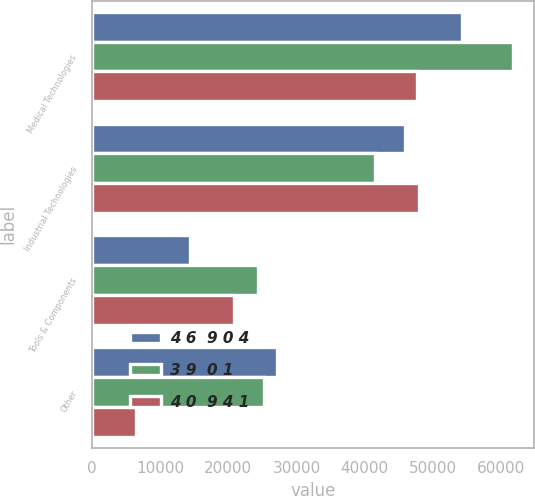<chart> <loc_0><loc_0><loc_500><loc_500><stacked_bar_chart><ecel><fcel>Medical Technologies<fcel>Industrial Technologies<fcel>Tools & Components<fcel>Other<nl><fcel>4 6  9 0 4<fcel>54212<fcel>45868<fcel>14418<fcel>27145<nl><fcel>3 9  0 1<fcel>61725<fcel>41548<fcel>24375<fcel>25194<nl><fcel>4 0  9 4 1<fcel>47618<fcel>48024<fcel>20908<fcel>6511<nl></chart> 